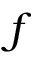<formula> <loc_0><loc_0><loc_500><loc_500>f</formula> 